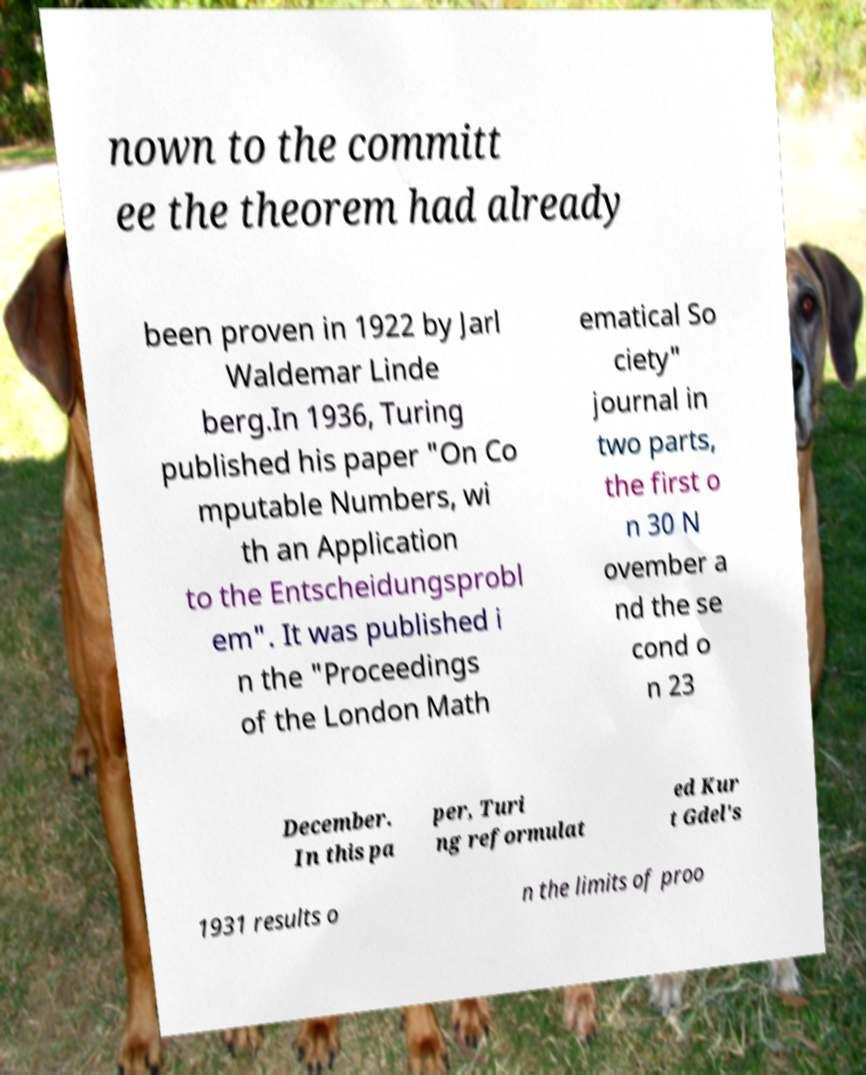I need the written content from this picture converted into text. Can you do that? nown to the committ ee the theorem had already been proven in 1922 by Jarl Waldemar Linde berg.In 1936, Turing published his paper "On Co mputable Numbers, wi th an Application to the Entscheidungsprobl em". It was published i n the "Proceedings of the London Math ematical So ciety" journal in two parts, the first o n 30 N ovember a nd the se cond o n 23 December. In this pa per, Turi ng reformulat ed Kur t Gdel's 1931 results o n the limits of proo 